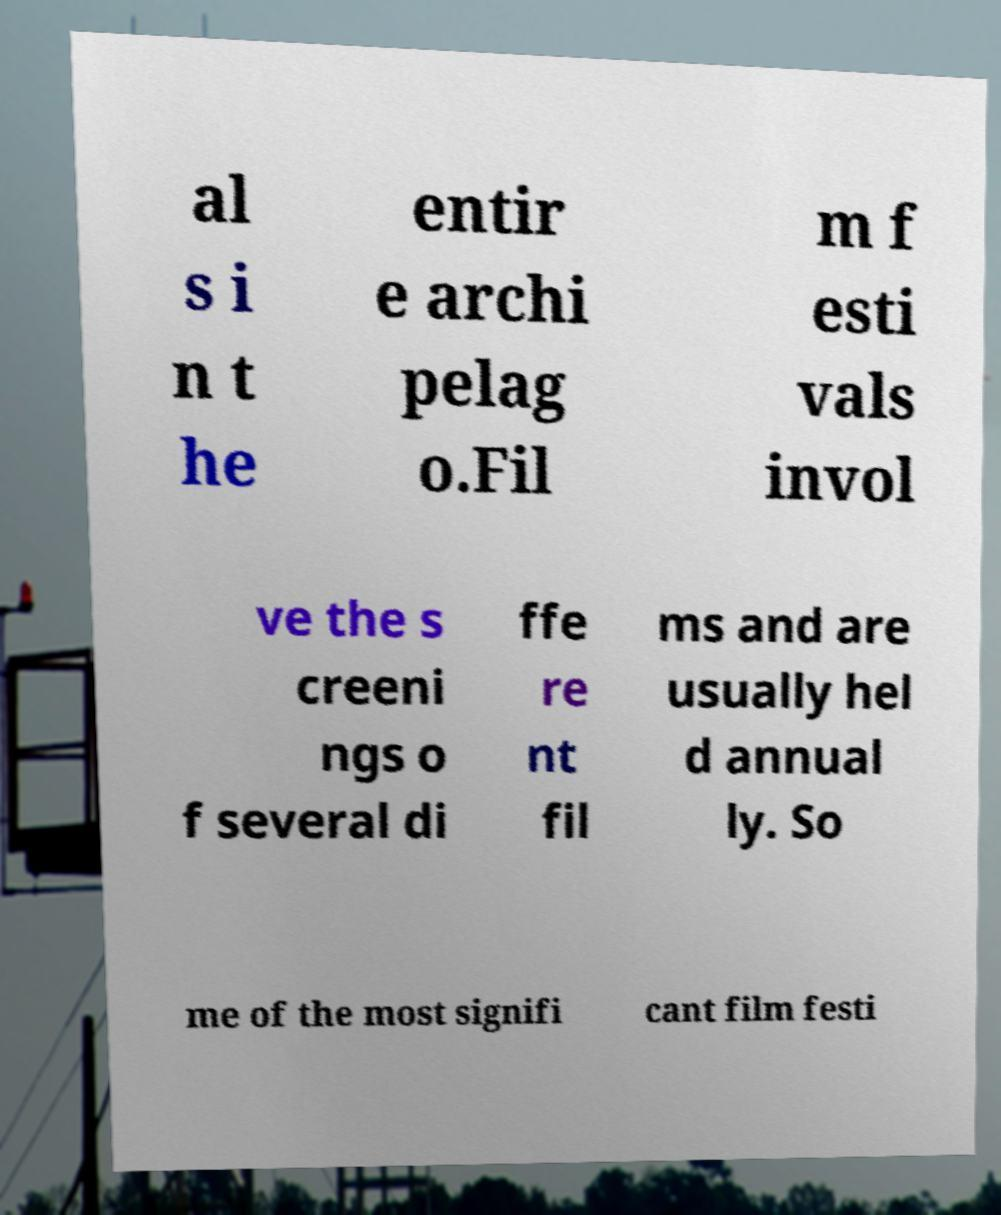Can you read and provide the text displayed in the image?This photo seems to have some interesting text. Can you extract and type it out for me? al s i n t he entir e archi pelag o.Fil m f esti vals invol ve the s creeni ngs o f several di ffe re nt fil ms and are usually hel d annual ly. So me of the most signifi cant film festi 